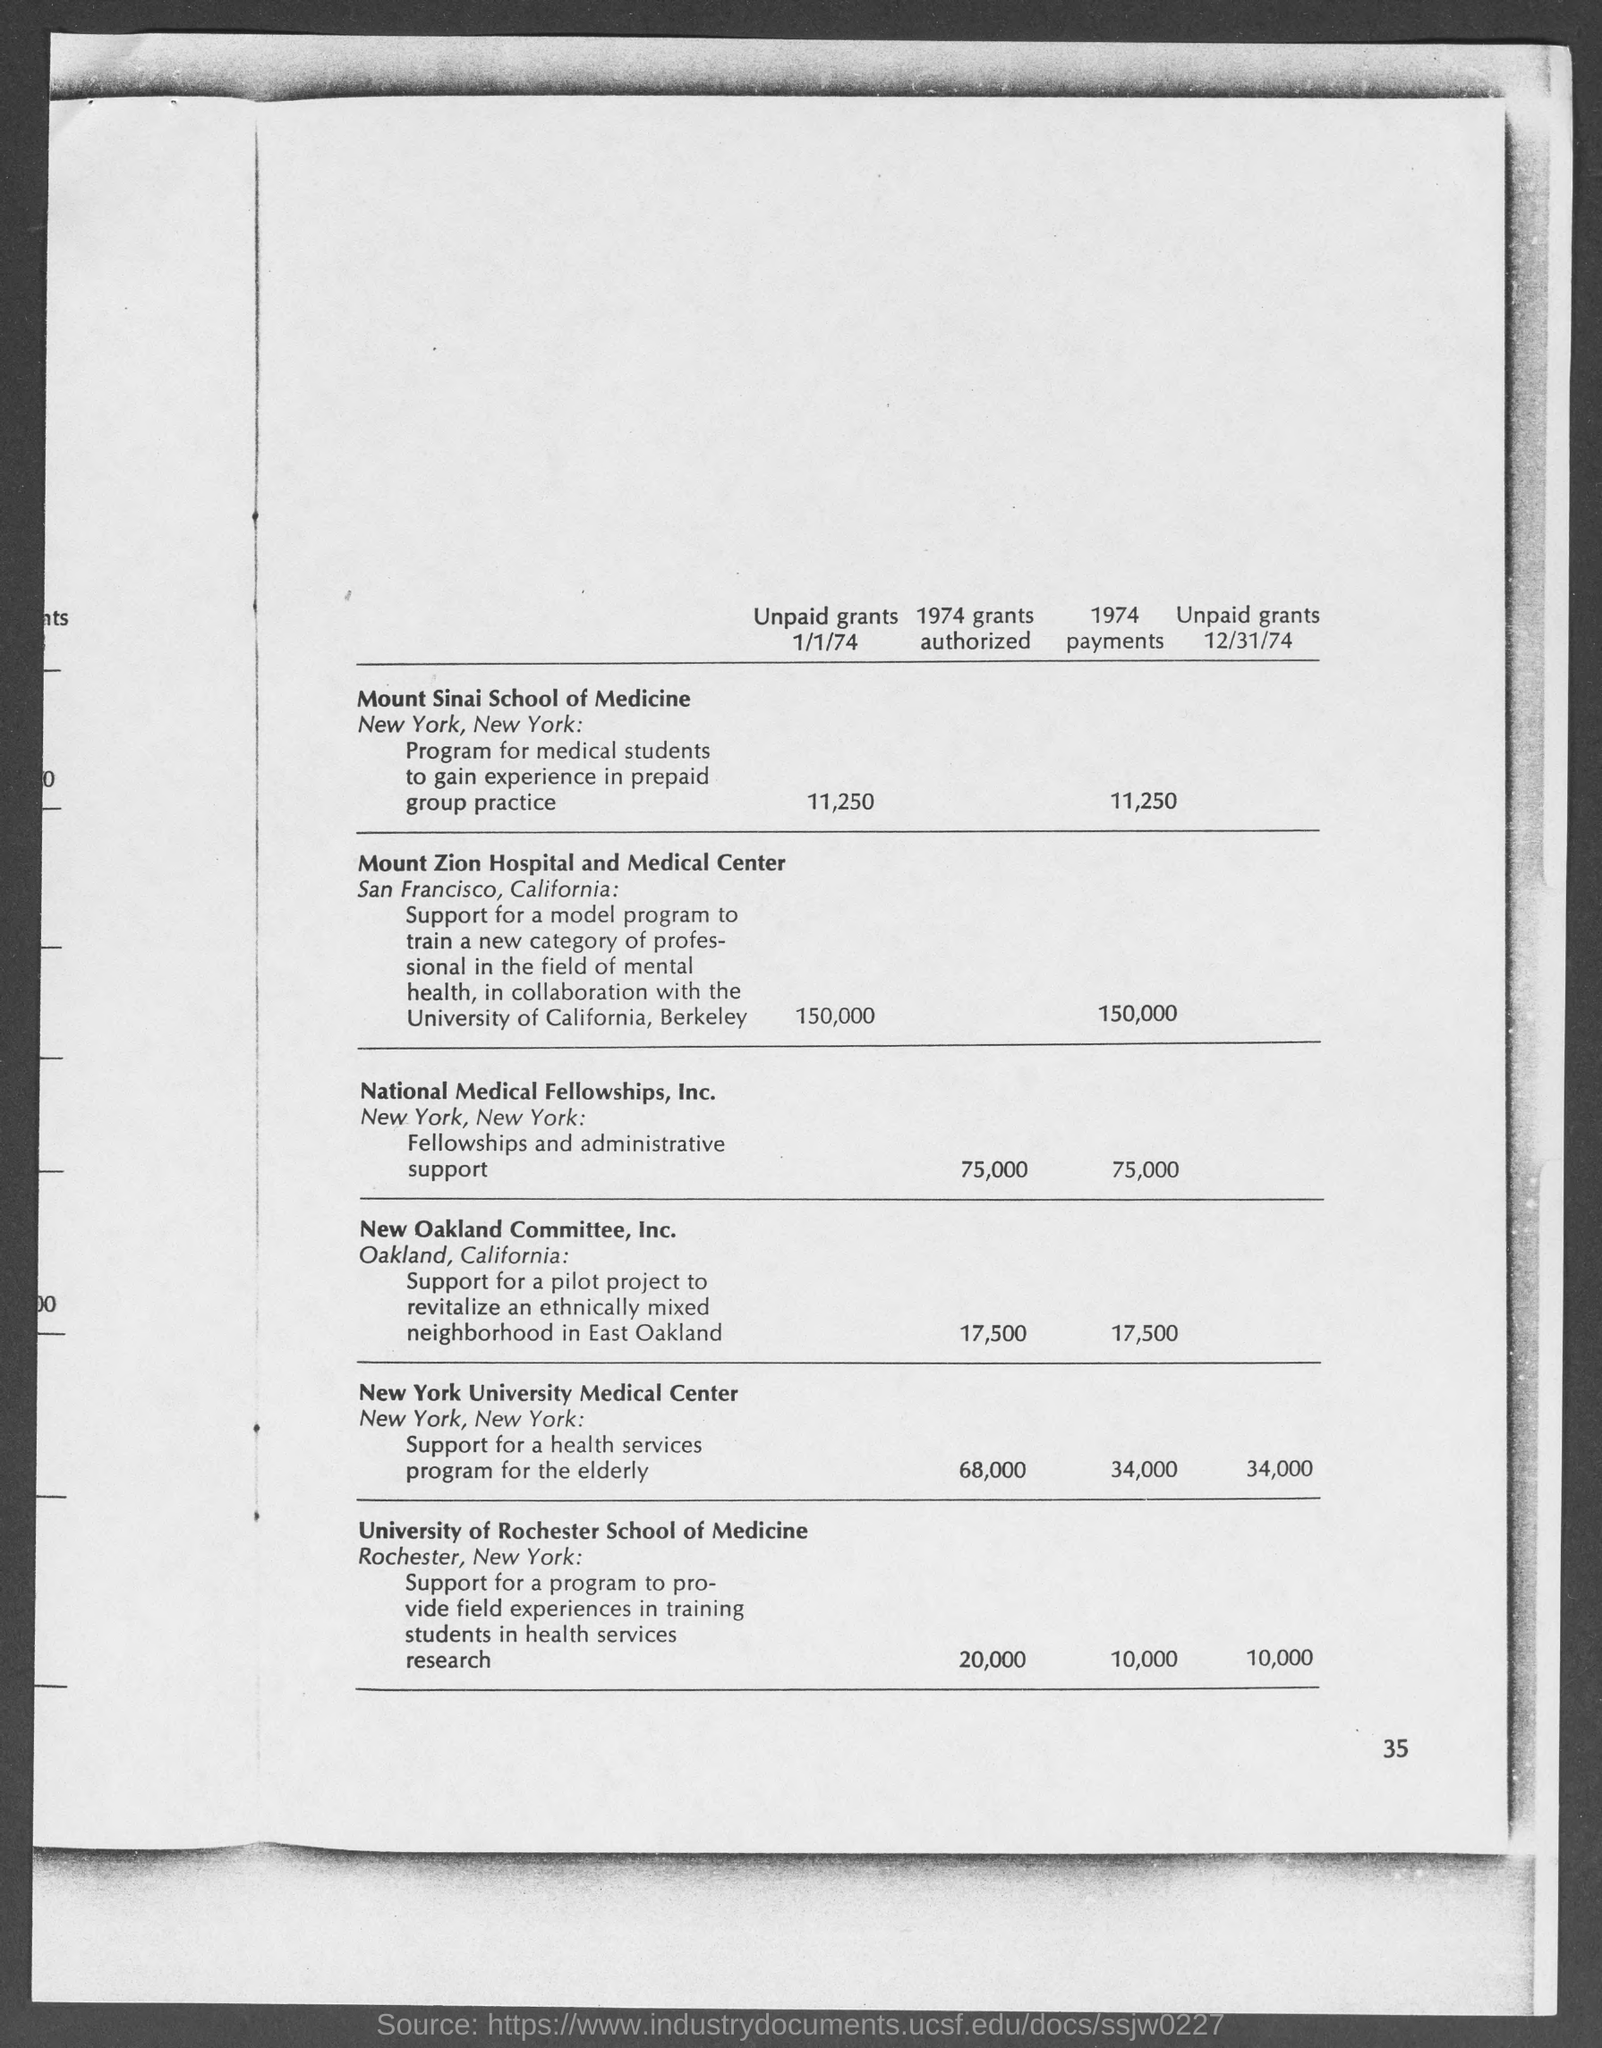What is the amount of unpaid grants 1/1/74 for mount sinai school of medicine ?
Offer a terse response. 11,250. What is the amount of unpaid grants 1/1/74 for mount zion hospital and medical center ?
Provide a succinct answer. $150,000. What is the amount of 1974 grants authorized for national medical fellowships, inc. ?
Give a very brief answer. 75,000. What is the amount of 1974 grants authorized for new oakland committee, inc.?
Your response must be concise. 17,500. What is the amount of 1974 grants authorized for university of rochester school of medicine ?
Your response must be concise. 20,000. What is the amount of 1974 payments for mount sinai school of medicine ?
Offer a terse response. 11,250. What is the amount of 1974 payments for mount zion hospital and medical center ?
Make the answer very short. $150,000. What is the amount of 1974 payments for national medical fellowships, inc.?
Your response must be concise. 75,000. What is the amount of 1974 payments for new oakland committee, inc.?
Make the answer very short. 17,500. 